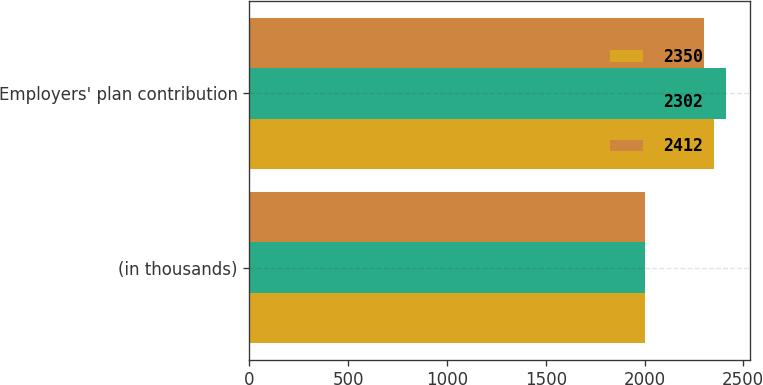Convert chart. <chart><loc_0><loc_0><loc_500><loc_500><stacked_bar_chart><ecel><fcel>(in thousands)<fcel>Employers' plan contribution<nl><fcel>2350<fcel>2004<fcel>2350<nl><fcel>2302<fcel>2003<fcel>2412<nl><fcel>2412<fcel>2002<fcel>2302<nl></chart> 